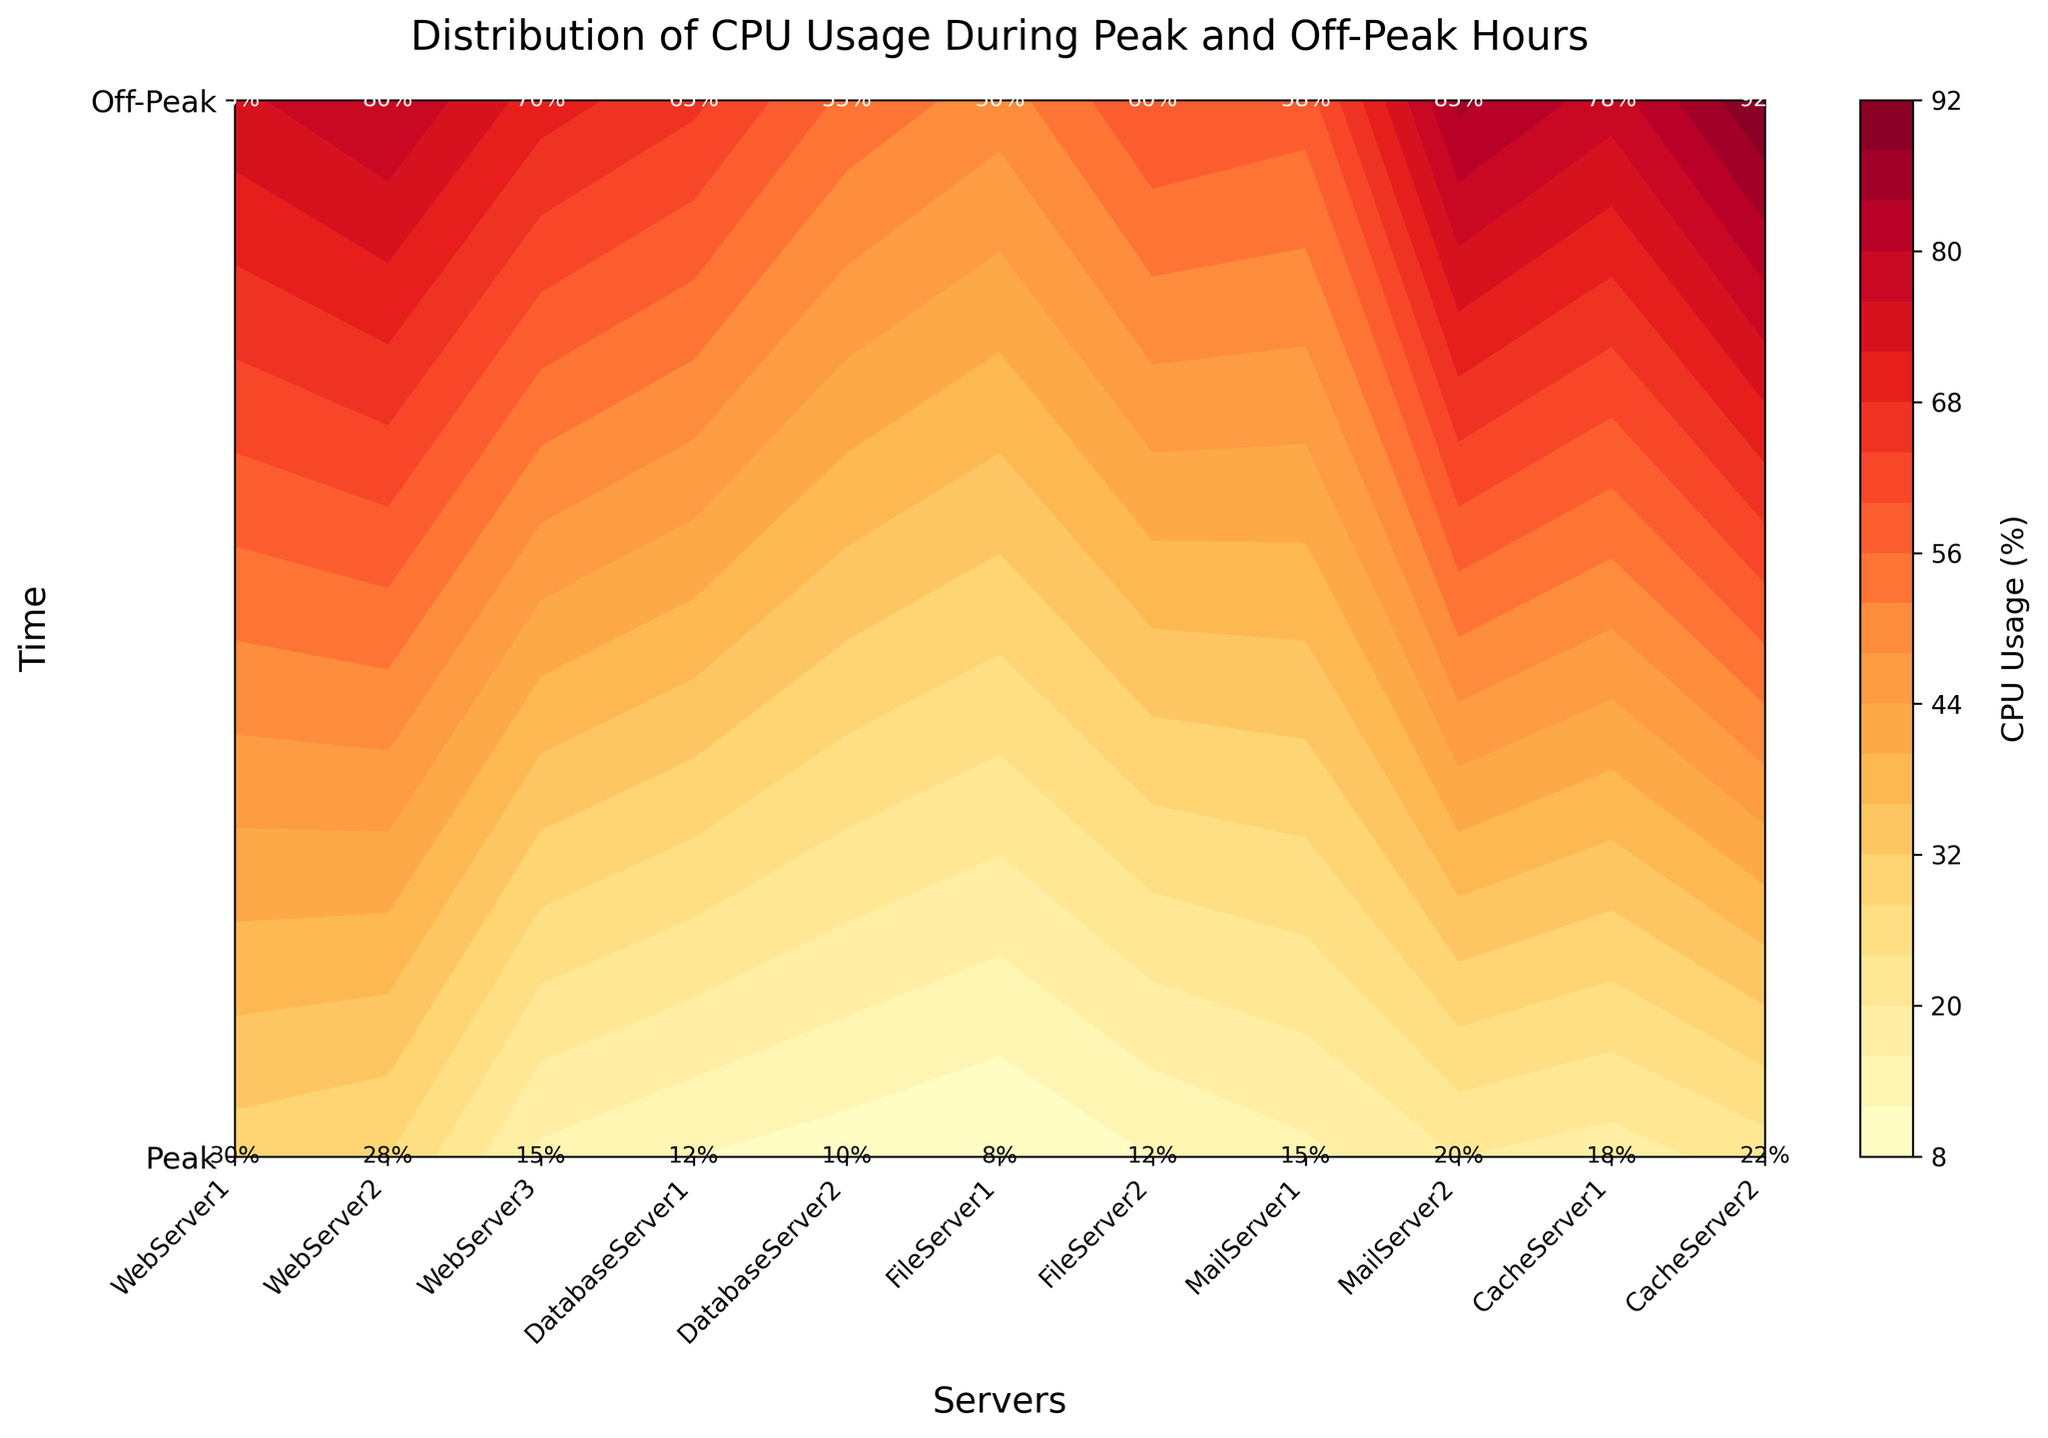What's the title of the plot? The title is typically displayed at the top of the plot. In this case, the title is "Distribution of CPU Usage During Peak and Off-Peak Hours" as described in the provided code.
Answer: Distribution of CPU Usage During Peak and Off-Peak Hours How many servers are included in the plot? The plot includes all the unique server names along the x-axis. The data lists 10 unique servers, so the x-axis should have labels for these 10 servers.
Answer: 10 Which server has the highest CPU usage during peak hours? Scan the contour plot values for 'Peak' which will be the first row in the plot. Identify the highest value and cross-check with the server label on the x-axis. The highest value is 92% for the server labeled as WebServer3.
Answer: WebServer3 What is the CPU usage of DatabaseServer1 during off-peak hours? Locate the “Off-Peak” label on the y-axis and find the corresponding grid cell for DatabaseServer1 on the x-axis. The CPU usage value is 15%.
Answer: 15% Which time period shows higher overall CPU usage, Peak or Off-Peak? Observe the contours for both time periods. The peak hours contours have higher values (ranging from 50% to 92%), while off-peak hours contours have lower values (ranging from 8% to 30%). Thus, peak hours show higher overall CPU usage.
Answer: Peak Between CacheServer1 and CacheServer2, which has higher CPU usage during off-peak hours? Locate the row for “Off-Peak” and compare the CPU usage values for CacheServer1 and CacheServer2. CacheServer1 has 30%, and CacheServer2 has 28%, so CacheServer1 has higher CPU usage.
Answer: CacheServer1 What is the range of CPU usage values shown in the color bar? Examine the color bar on the right side of the plot. The minimum and maximum values of the color bar represent the range. The range is from approximately 8% to 92%.
Answer: 8% to 92% Which server shows the most significant difference in CPU usage between Peak and Off-Peak hours? Calculate the difference in CPU usage for each server by subtracting the off-peak value from the peak value for each server. The server with the highest difference is WebServer3 with a difference of 92% (Peak) - 22% (Off-Peak) = 70%.
Answer: WebServer3 What is the average CPU usage of the web servers (WebServer1, WebServer2, WebServer3) during peak hours? Add the peak CPU usage of WebServer1 (85%), WebServer2 (78%), and WebServer3 (92%) then divide by the number of servers (3). The calculation is (85 + 78 + 92) / 3, which equals 85%.
Answer: 85% Which server category (WebServer, DatabaseServer, FileServer, MailServer, CacheServer) has the highest average CPU usage during peak hours? Compute the average CPU usage for each server category during peak hours. WebServers: (85+78+92)/3 = 85%, DatabaseServers: (70+65)/2 = 67.5%, FileServers: (55+50)/2 = 52.5%, MailServers: (60+58)/2 = 59%, CacheServers: (75+80)/2 = 77.5%. The highest average is for WebServers at 85%.
Answer: WebServers 